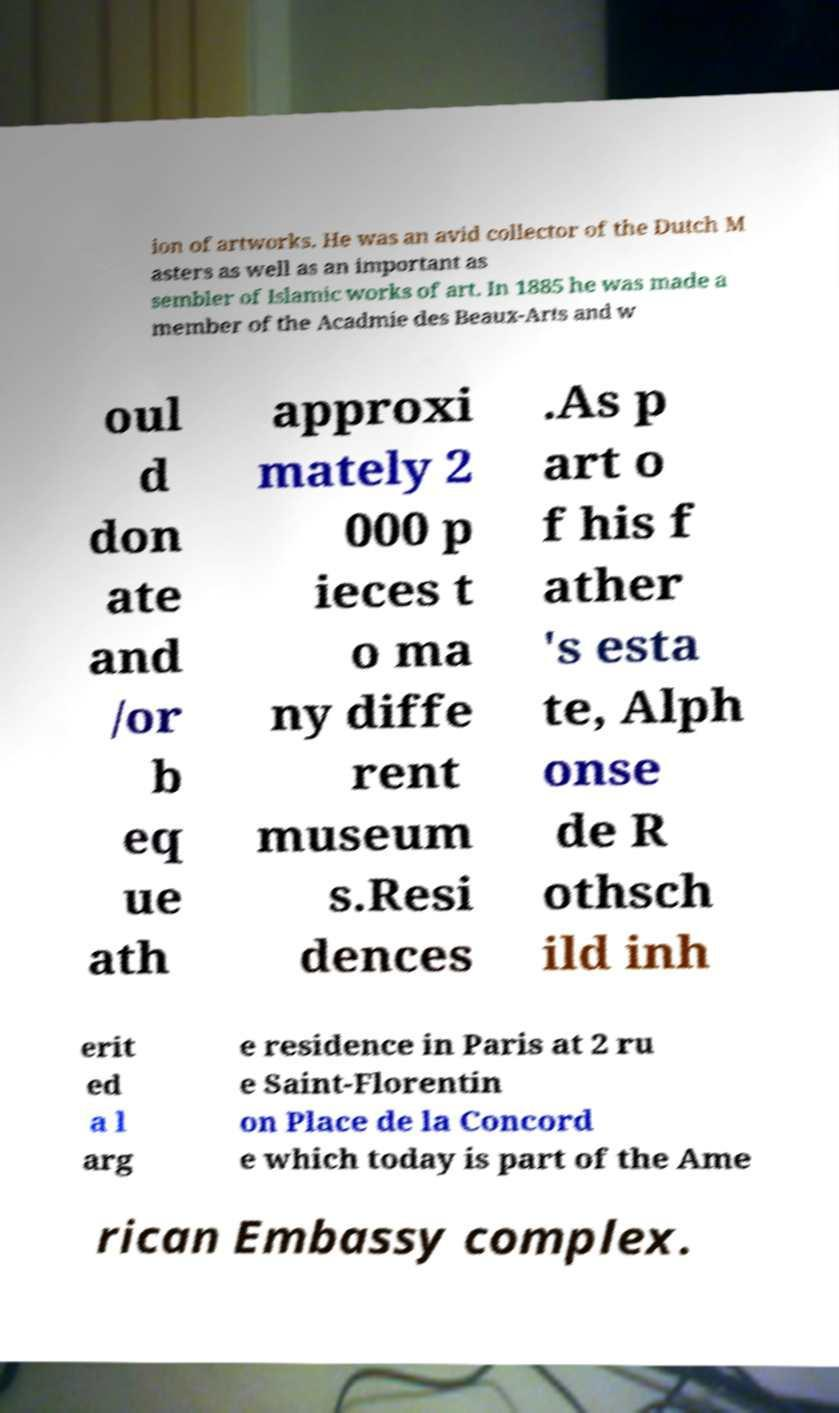Please identify and transcribe the text found in this image. ion of artworks. He was an avid collector of the Dutch M asters as well as an important as sembler of Islamic works of art. In 1885 he was made a member of the Acadmie des Beaux-Arts and w oul d don ate and /or b eq ue ath approxi mately 2 000 p ieces t o ma ny diffe rent museum s.Resi dences .As p art o f his f ather 's esta te, Alph onse de R othsch ild inh erit ed a l arg e residence in Paris at 2 ru e Saint-Florentin on Place de la Concord e which today is part of the Ame rican Embassy complex. 